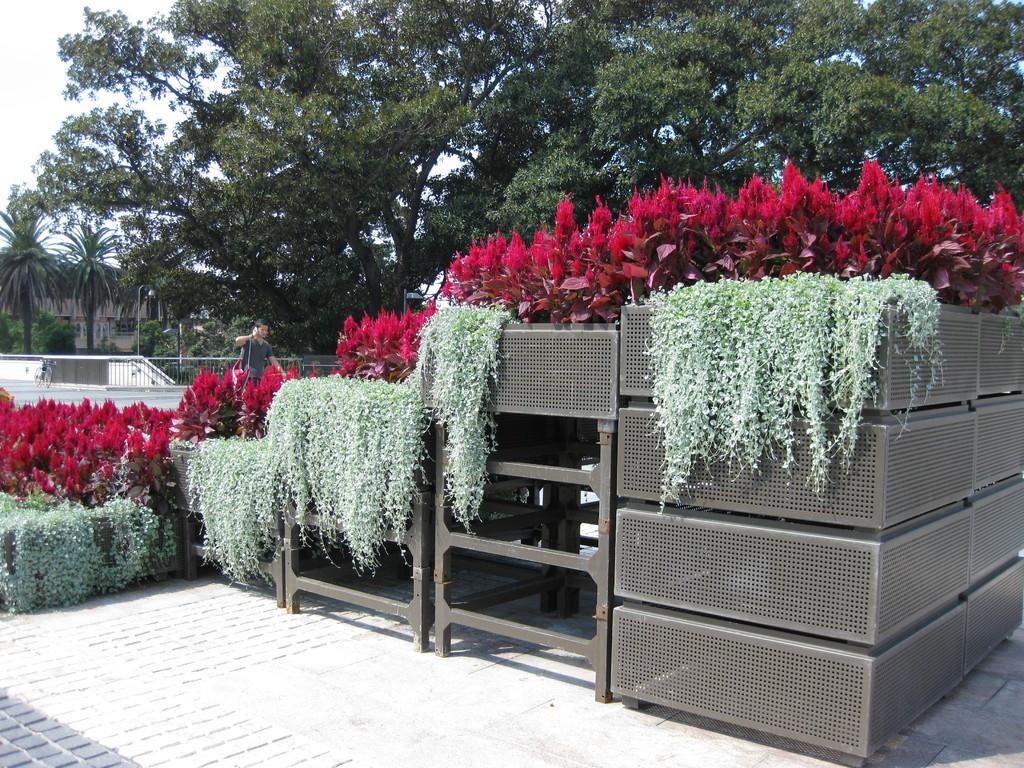What is depicted on the metal object in the image? There are planets depicted on a metal object in the image. What type of living organism can be seen in the image? There is a plant in the image. Can you describe the person visible behind the plant? A man is visible behind the plant. What type of barrier is present in the image? There is metal fencing in the image. What can be seen in the background of the image? Trees are present in the background of the image. What route does the person take to reach the condition mentioned in the image? There is no person, route, or condition mentioned in the image. 